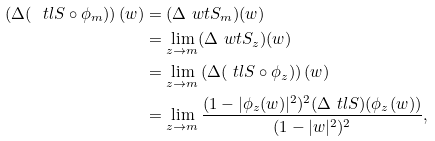<formula> <loc_0><loc_0><loc_500><loc_500>\left ( \Delta ( \ t l { S } \circ \phi _ { m } ) \right ) ( w ) & = ( \Delta \ w t { S _ { m } } ) ( w ) \\ & = \lim _ { z \to m } ( \Delta \ w t { S _ { z } } ) ( w ) \\ & = \lim _ { z \to m } \left ( \Delta ( \ t l { S } \circ \phi _ { z } ) \right ) ( w ) \\ & = \lim _ { z \to m } \frac { ( 1 - | \phi _ { z } ( w ) | ^ { 2 } ) ^ { 2 } ( \Delta \ t l { S } ) ( \phi _ { z } ( w ) ) } { ( 1 - | w | ^ { 2 } ) ^ { 2 } } ,</formula> 